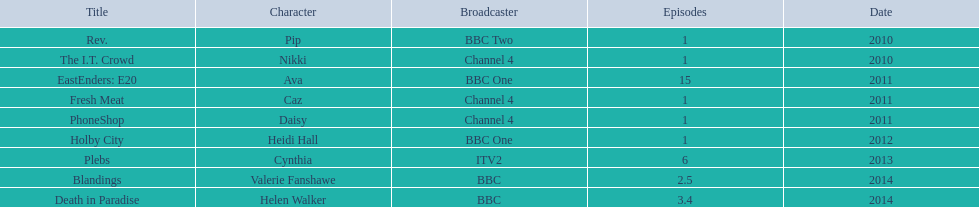Which media outlet presented three programs, but each had just a single episode? Channel 4. 